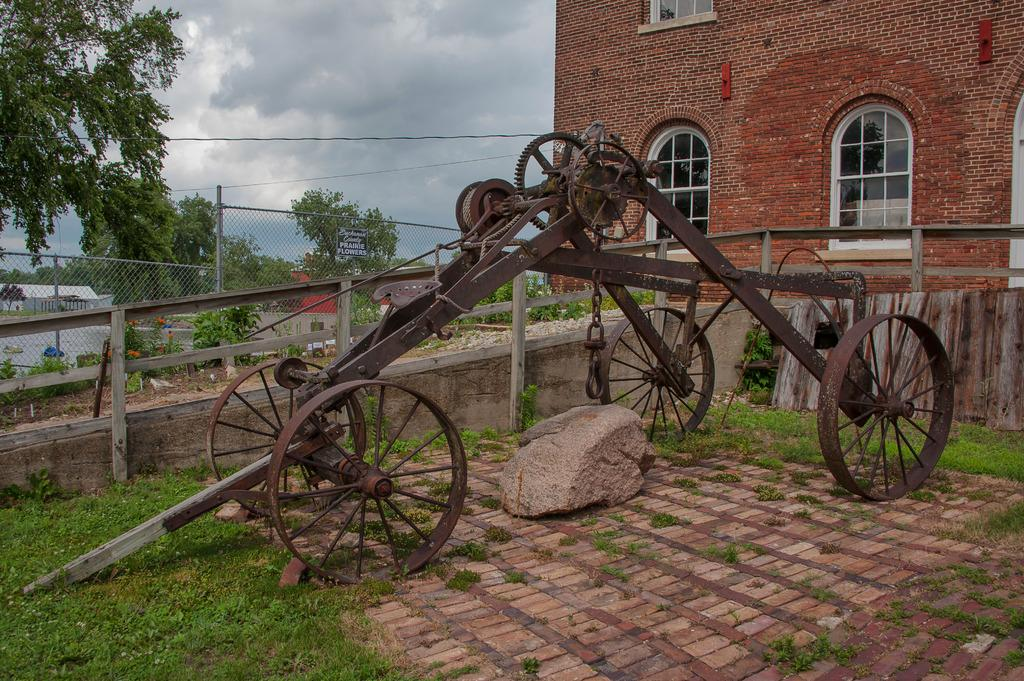What is located in the center of the image? There is a cart in the center of the image. What can be seen on the right side of the image? There is a building on the right side of the image. What type of vegetation is visible in the background of the image? There are trees in the background of the image. What else can be seen in the background of the image? There is a mesh and the sky visible in the background of the image. What type of nerve can be seen in the image? There is no nerve present in the image. What kind of art is displayed on the cart in the image? The image does not show any art on the cart; it only shows the cart itself. 